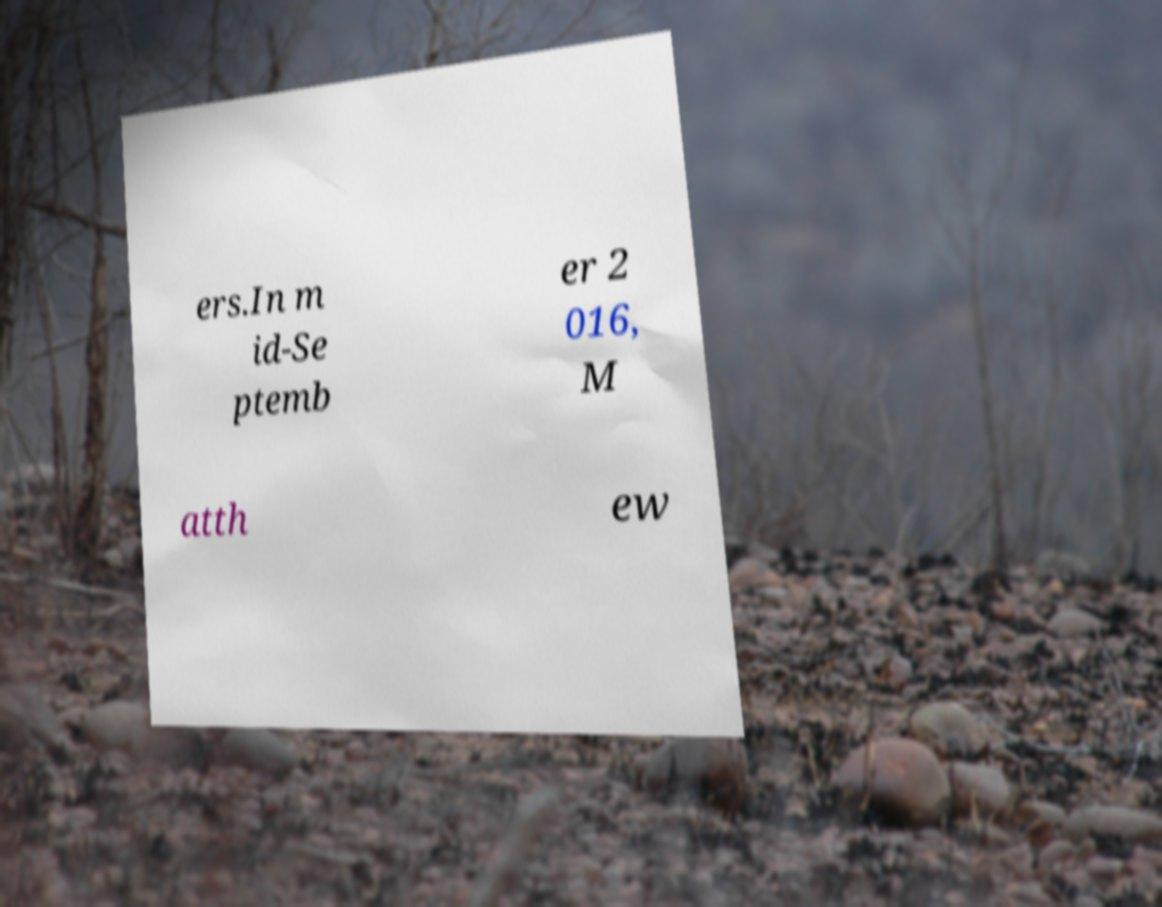I need the written content from this picture converted into text. Can you do that? ers.In m id-Se ptemb er 2 016, M atth ew 